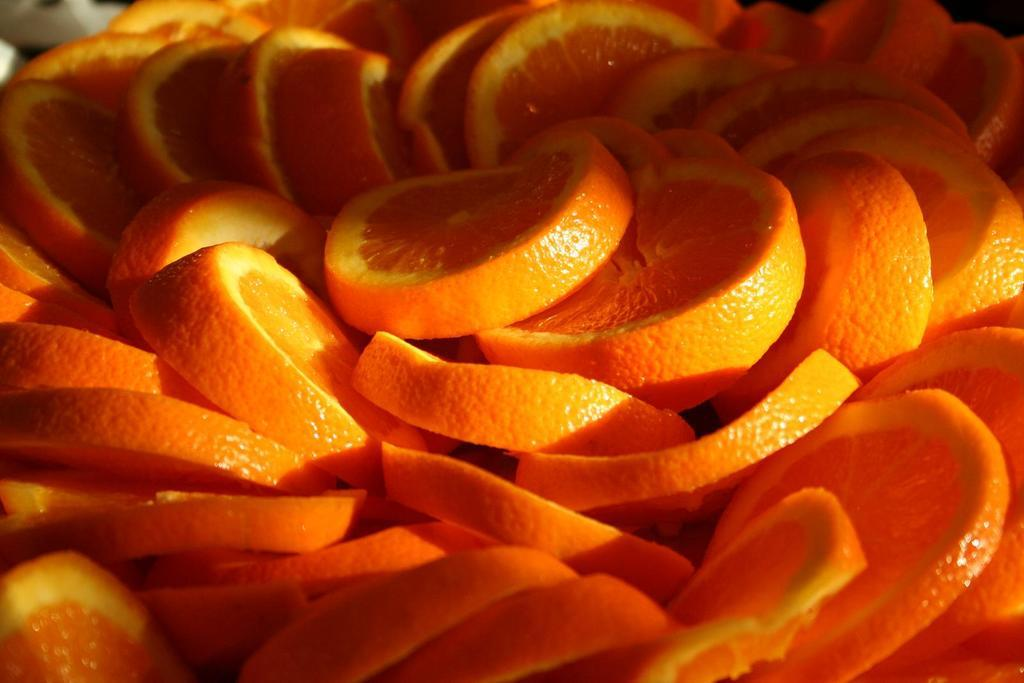What type of food can be seen in the image? There are orange slices in the image. How many laborers are working with the rabbits in the image? There are no laborers or rabbits present in the image; it only features orange slices. 